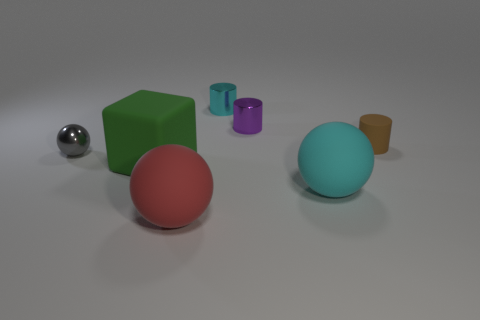Are there any things made of the same material as the red ball?
Provide a succinct answer. Yes. What is the material of the cyan thing behind the small shiny thing in front of the small matte cylinder?
Provide a succinct answer. Metal. There is a tiny object that is left of the small purple metallic object and behind the tiny brown rubber thing; what is its material?
Ensure brevity in your answer.  Metal. Are there an equal number of small gray balls behind the tiny gray object and small cyan metal blocks?
Your response must be concise. Yes. How many other large objects are the same shape as the gray shiny object?
Your answer should be very brief. 2. What size is the metal cylinder that is right of the cyan thing to the left of the cyan object in front of the small gray metallic thing?
Offer a very short reply. Small. Do the large ball that is on the right side of the cyan metal object and the red sphere have the same material?
Provide a short and direct response. Yes. Is the number of big red balls that are right of the tiny rubber thing the same as the number of large green cubes that are on the left side of the green block?
Your answer should be compact. Yes. Is there any other thing that has the same size as the purple thing?
Give a very brief answer. Yes. There is another cyan object that is the same shape as the small matte thing; what is its material?
Give a very brief answer. Metal. 